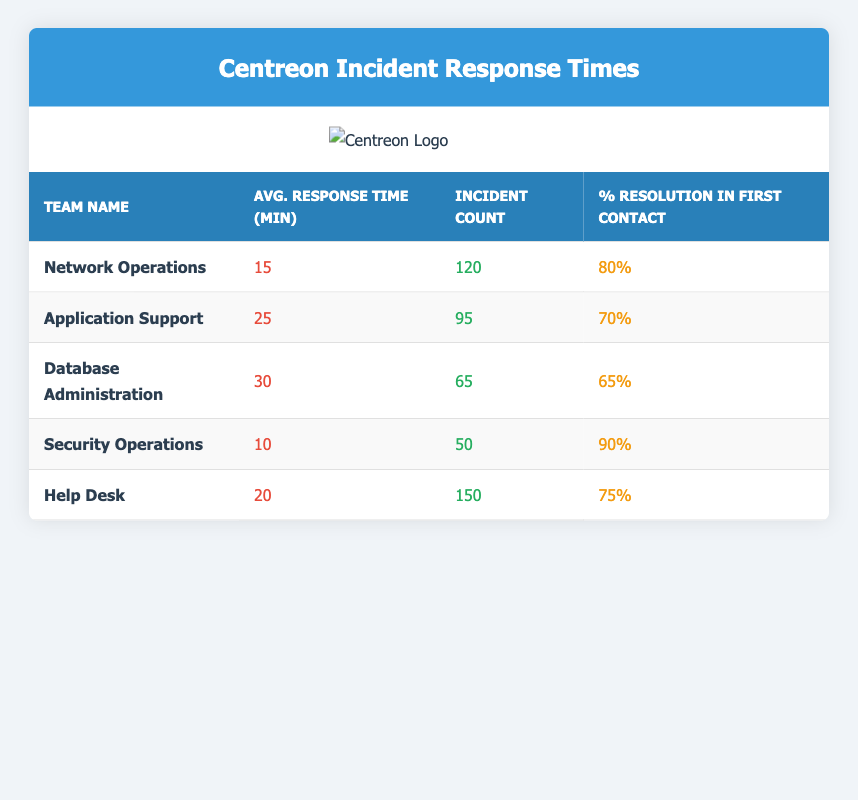What is the average response time for the Network Operations team? The table lists the average response time for each team, and for the Network Operations team, the average response time is specified as 15 minutes.
Answer: 15 minutes How many incidents did the Help Desk handle? From the table, the incident count for the Help Desk team is directly given as 150.
Answer: 150 Which team has the highest percentage of resolution in the first contact? By examining the percentage of resolution in the first contact for each team, Security Operations has the highest at 90%.
Answer: Security Operations What is the average response time for teams with more than 100 incidents? The teams with more than 100 incidents are Network Operations (15 min) and Help Desk (20 min). To find the average, we calculate (15 + 20) / 2 = 17.5 minutes.
Answer: 17.5 minutes Is the average response time for Database Administration less than 30 minutes? The average response time for Database Administration is 30 minutes, which is not less than 30 minutes. Thus, it is false.
Answer: No What is the difference in percentage of first contact resolution between the Security Operations team and the Application Support team? Security Operations has a percentage of 90% and Application Support has 70%. The difference is calculated as 90% - 70% = 20%.
Answer: 20% Which team has the lowest average response time and what is it? By comparing the average response times of all teams, Security Operations has the lowest at 10 minutes.
Answer: Security Operations, 10 minutes If we combine the incident counts for Network Operations and Database Administration, what would be their total? The incident counts are 120 for Network Operations and 65 for Database Administration. Adding them gives 120 + 65 = 185 incidents in total.
Answer: 185 incidents How does the average response time of Application Support compare to the Help Desk? The average response time for Application Support is 25 minutes, while for Help Desk it is 20 minutes. Since 25 minutes is greater than 20 minutes, Application Support has a longer response time than Help Desk.
Answer: Application Support has a longer response time 